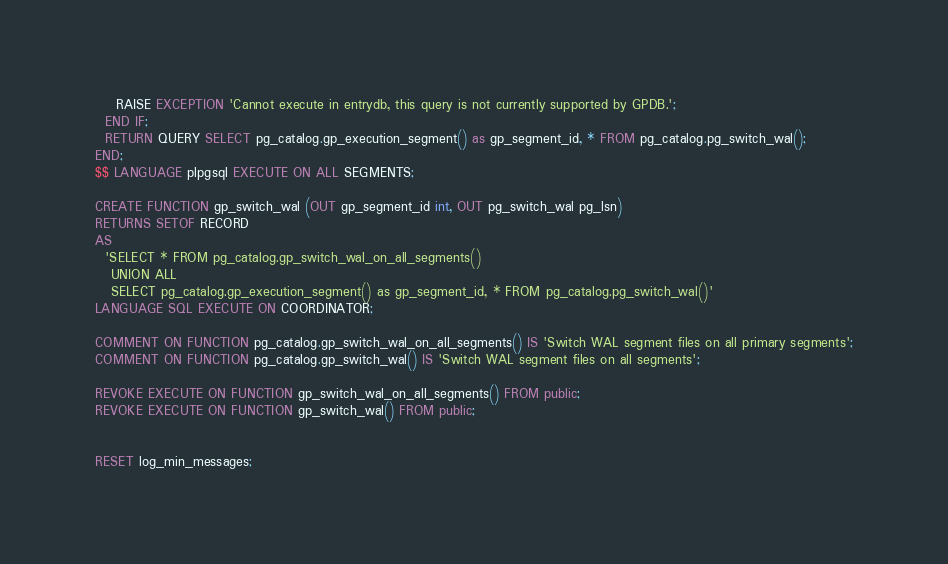<code> <loc_0><loc_0><loc_500><loc_500><_SQL_>    RAISE EXCEPTION 'Cannot execute in entrydb, this query is not currently supported by GPDB.';
  END IF;
  RETURN QUERY SELECT pg_catalog.gp_execution_segment() as gp_segment_id, * FROM pg_catalog.pg_switch_wal();
END;
$$ LANGUAGE plpgsql EXECUTE ON ALL SEGMENTS;

CREATE FUNCTION gp_switch_wal (OUT gp_segment_id int, OUT pg_switch_wal pg_lsn)
RETURNS SETOF RECORD
AS
  'SELECT * FROM pg_catalog.gp_switch_wal_on_all_segments()
   UNION ALL
   SELECT pg_catalog.gp_execution_segment() as gp_segment_id, * FROM pg_catalog.pg_switch_wal()'
LANGUAGE SQL EXECUTE ON COORDINATOR;

COMMENT ON FUNCTION pg_catalog.gp_switch_wal_on_all_segments() IS 'Switch WAL segment files on all primary segments';
COMMENT ON FUNCTION pg_catalog.gp_switch_wal() IS 'Switch WAL segment files on all segments';

REVOKE EXECUTE ON FUNCTION gp_switch_wal_on_all_segments() FROM public;
REVOKE EXECUTE ON FUNCTION gp_switch_wal() FROM public;


RESET log_min_messages;
</code> 